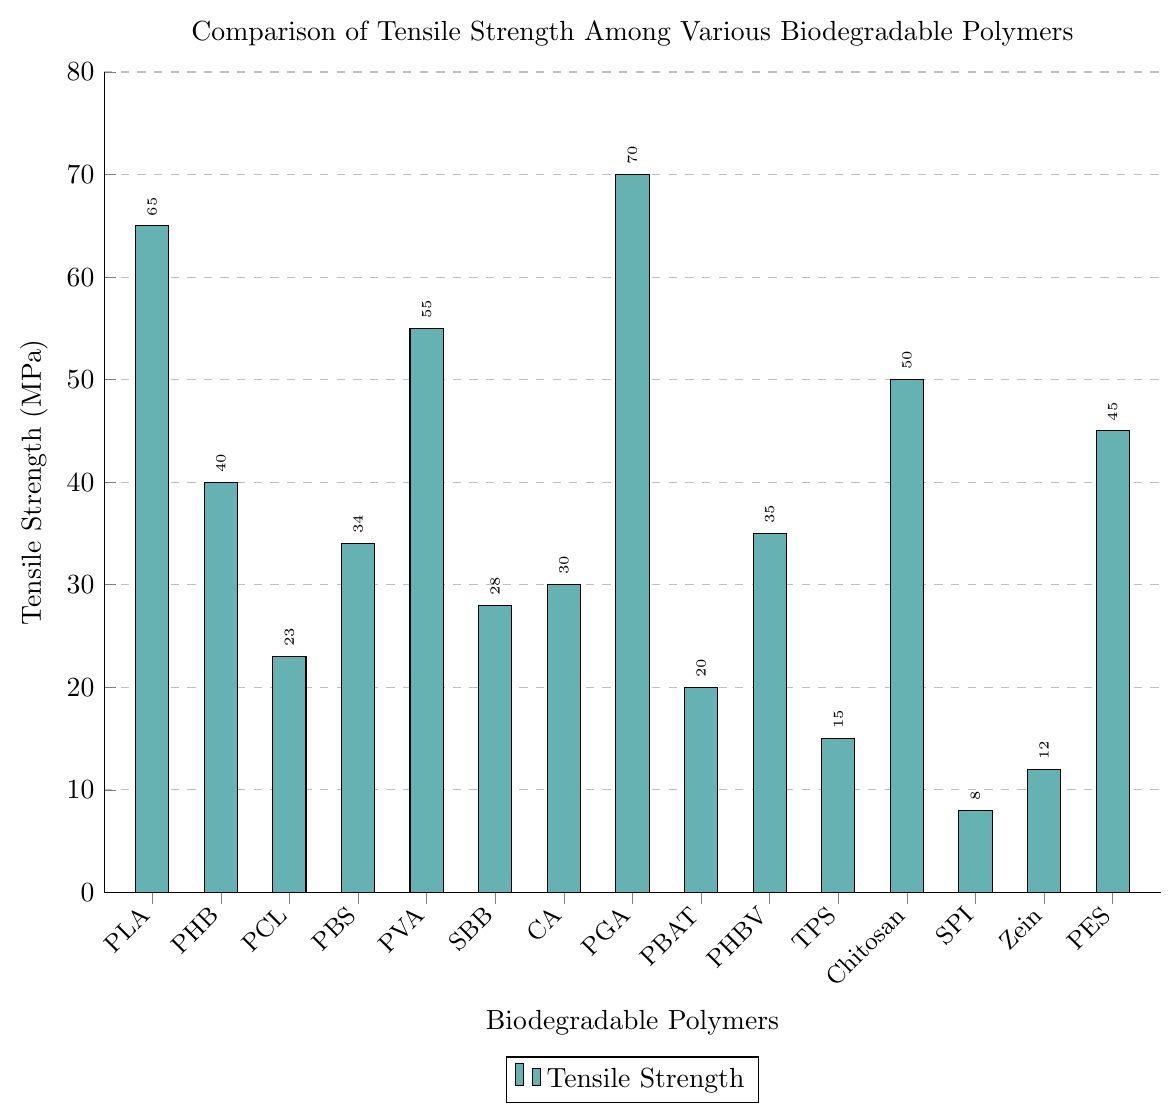What's the polymer with the highest tensile strength? Identify the bar with the greatest height. The highest bar corresponds to the polymer with the highest tensile strength. In this case, it's the bar labeled "PGA."
Answer: Polyglycolic acid (PGA) Which polymer has the lowest tensile strength, and what is its value? Look for the shortest bar in the chart. The shortest bar corresponds to the polymer with the lowest tensile strength. In this case, it's the bar labeled "SPI." The tensile strength value shown near this bar is 8 MPa.
Answer: Soy protein isolate (SPI), 8 MPa Compare the tensile strengths of Polylactic acid (PLA) and Polyglycolic acid (PGA). Which one is higher, and by how much? Locate the bars for PLA and PGA. PLA has a tensile strength of 65 MPa, and PGA has a tensile strength of 70 MPa. Calculate the difference: 70 - 65 = 5 MPa.
Answer: Polyglycolic acid (PGA) by 5 MPa What's the average tensile strength of the polymers with tensile strengths greater than 40 MPa? Identify the polymers with tensile strengths above 40 MPa: PLA (65), Chitosan (50), PVA (55), PGA (70), and PES (45). Sum these values: 65 + 50 + 55 + 70 + 45 = 285. Divide by the number of polymers: 285 / 5 = 57.
Answer: 57 MPa Which polymer has the most similar tensile strength to Chitosan, and what is the value? First, find the tensile strength of Chitosan, which is 50 MPa, then look for bars with tensile strengths close to this value. The closest is PES with a tensile strength of 45 MPa.
Answer: Polyethylene succinate (PES), 45 MPa How many polymers have a tensile strength between 20 and 40 MPa? Count the bars that fall within the range of 20 to 40 MPa. These are PHB (40), PCL (23), PBS (34), SBB (28), CA (30), PBAT (20), and PHBV (35): 7 polymers in total.
Answer: 7 What is the median tensile strength value of the given polymers? Arrange the tensile strengths in ascending order: 8, 12, 15, 20, 23, 28, 30, 34, 35, 40, 45, 50, 55, 65, 70. The middle value (8th in a list of 15) is 34.
Answer: 34 MPa Compare the tensile strength of Polyvinyl alcohol (PVA) to the average tensile strength of Cellulose acetate (CA) and Starch-based blends (SBB). Which is higher, and by how much? Calculate the average tensile strength of CA (30) and SBB (28): (30 + 28) / 2 = 29 MPa. The tensile strength of PVA is 55 MPa. Find the difference: 55 - 29 = 26 MPa.
Answer: Polyvinyl alcohol (PVA) by 26 MPa 